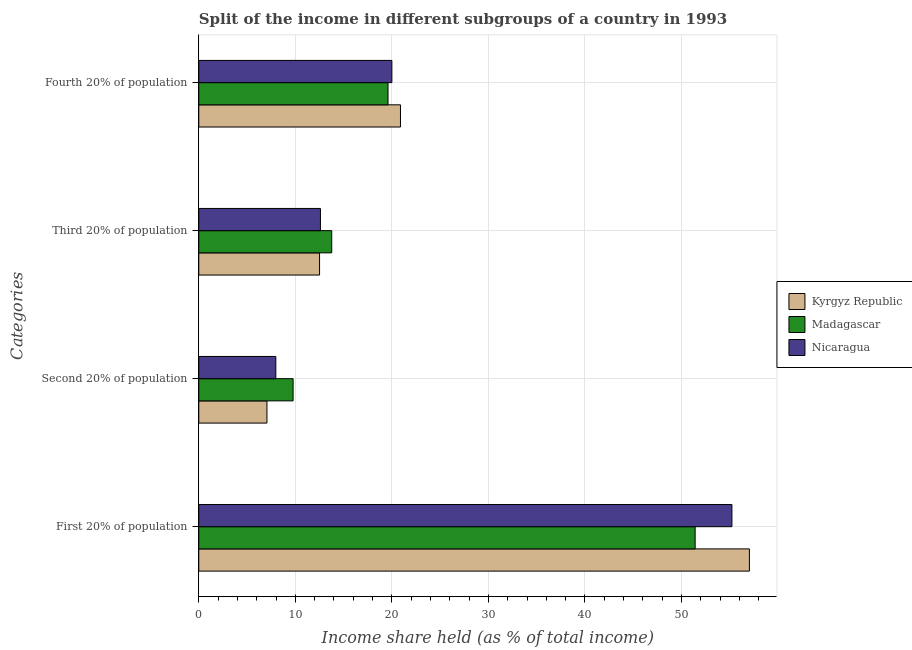How many different coloured bars are there?
Make the answer very short. 3. Are the number of bars per tick equal to the number of legend labels?
Provide a succinct answer. Yes. Are the number of bars on each tick of the Y-axis equal?
Offer a very short reply. Yes. How many bars are there on the 3rd tick from the top?
Your answer should be very brief. 3. What is the label of the 3rd group of bars from the top?
Your response must be concise. Second 20% of population. What is the share of the income held by second 20% of the population in Madagascar?
Provide a short and direct response. 9.77. Across all countries, what is the maximum share of the income held by second 20% of the population?
Offer a very short reply. 9.77. Across all countries, what is the minimum share of the income held by fourth 20% of the population?
Offer a very short reply. 19.6. In which country was the share of the income held by first 20% of the population maximum?
Ensure brevity in your answer.  Kyrgyz Republic. In which country was the share of the income held by second 20% of the population minimum?
Make the answer very short. Kyrgyz Republic. What is the total share of the income held by first 20% of the population in the graph?
Offer a terse response. 163.66. What is the difference between the share of the income held by first 20% of the population in Madagascar and that in Nicaragua?
Your answer should be compact. -3.81. What is the difference between the share of the income held by fourth 20% of the population in Madagascar and the share of the income held by second 20% of the population in Kyrgyz Republic?
Give a very brief answer. 12.54. What is the average share of the income held by first 20% of the population per country?
Offer a terse response. 54.55. What is the difference between the share of the income held by second 20% of the population and share of the income held by first 20% of the population in Kyrgyz Republic?
Offer a terse response. -49.97. What is the ratio of the share of the income held by second 20% of the population in Kyrgyz Republic to that in Nicaragua?
Provide a short and direct response. 0.88. What is the difference between the highest and the second highest share of the income held by third 20% of the population?
Ensure brevity in your answer.  1.17. What is the difference between the highest and the lowest share of the income held by fourth 20% of the population?
Make the answer very short. 1.29. Is the sum of the share of the income held by second 20% of the population in Nicaragua and Kyrgyz Republic greater than the maximum share of the income held by third 20% of the population across all countries?
Offer a terse response. Yes. What does the 2nd bar from the top in Second 20% of population represents?
Provide a succinct answer. Madagascar. What does the 3rd bar from the bottom in Fourth 20% of population represents?
Ensure brevity in your answer.  Nicaragua. Is it the case that in every country, the sum of the share of the income held by first 20% of the population and share of the income held by second 20% of the population is greater than the share of the income held by third 20% of the population?
Your answer should be very brief. Yes. Are all the bars in the graph horizontal?
Offer a very short reply. Yes. Are the values on the major ticks of X-axis written in scientific E-notation?
Offer a very short reply. No. What is the title of the graph?
Provide a succinct answer. Split of the income in different subgroups of a country in 1993. Does "Lesotho" appear as one of the legend labels in the graph?
Keep it short and to the point. No. What is the label or title of the X-axis?
Provide a short and direct response. Income share held (as % of total income). What is the label or title of the Y-axis?
Ensure brevity in your answer.  Categories. What is the Income share held (as % of total income) in Kyrgyz Republic in First 20% of population?
Make the answer very short. 57.03. What is the Income share held (as % of total income) in Madagascar in First 20% of population?
Offer a terse response. 51.41. What is the Income share held (as % of total income) of Nicaragua in First 20% of population?
Your answer should be compact. 55.22. What is the Income share held (as % of total income) of Kyrgyz Republic in Second 20% of population?
Give a very brief answer. 7.06. What is the Income share held (as % of total income) of Madagascar in Second 20% of population?
Your answer should be compact. 9.77. What is the Income share held (as % of total income) in Nicaragua in Second 20% of population?
Keep it short and to the point. 7.98. What is the Income share held (as % of total income) of Kyrgyz Republic in Third 20% of population?
Give a very brief answer. 12.51. What is the Income share held (as % of total income) of Madagascar in Third 20% of population?
Your response must be concise. 13.77. What is the Income share held (as % of total income) of Kyrgyz Republic in Fourth 20% of population?
Offer a very short reply. 20.89. What is the Income share held (as % of total income) in Madagascar in Fourth 20% of population?
Provide a short and direct response. 19.6. What is the Income share held (as % of total income) in Nicaragua in Fourth 20% of population?
Keep it short and to the point. 20. Across all Categories, what is the maximum Income share held (as % of total income) in Kyrgyz Republic?
Your answer should be compact. 57.03. Across all Categories, what is the maximum Income share held (as % of total income) in Madagascar?
Offer a terse response. 51.41. Across all Categories, what is the maximum Income share held (as % of total income) in Nicaragua?
Your answer should be compact. 55.22. Across all Categories, what is the minimum Income share held (as % of total income) of Kyrgyz Republic?
Your response must be concise. 7.06. Across all Categories, what is the minimum Income share held (as % of total income) in Madagascar?
Provide a short and direct response. 9.77. Across all Categories, what is the minimum Income share held (as % of total income) of Nicaragua?
Make the answer very short. 7.98. What is the total Income share held (as % of total income) in Kyrgyz Republic in the graph?
Offer a terse response. 97.49. What is the total Income share held (as % of total income) in Madagascar in the graph?
Your answer should be compact. 94.55. What is the total Income share held (as % of total income) of Nicaragua in the graph?
Provide a short and direct response. 95.8. What is the difference between the Income share held (as % of total income) of Kyrgyz Republic in First 20% of population and that in Second 20% of population?
Offer a terse response. 49.97. What is the difference between the Income share held (as % of total income) of Madagascar in First 20% of population and that in Second 20% of population?
Offer a terse response. 41.64. What is the difference between the Income share held (as % of total income) in Nicaragua in First 20% of population and that in Second 20% of population?
Provide a succinct answer. 47.24. What is the difference between the Income share held (as % of total income) of Kyrgyz Republic in First 20% of population and that in Third 20% of population?
Ensure brevity in your answer.  44.52. What is the difference between the Income share held (as % of total income) of Madagascar in First 20% of population and that in Third 20% of population?
Provide a short and direct response. 37.64. What is the difference between the Income share held (as % of total income) of Nicaragua in First 20% of population and that in Third 20% of population?
Offer a very short reply. 42.62. What is the difference between the Income share held (as % of total income) in Kyrgyz Republic in First 20% of population and that in Fourth 20% of population?
Offer a very short reply. 36.14. What is the difference between the Income share held (as % of total income) of Madagascar in First 20% of population and that in Fourth 20% of population?
Offer a terse response. 31.81. What is the difference between the Income share held (as % of total income) in Nicaragua in First 20% of population and that in Fourth 20% of population?
Ensure brevity in your answer.  35.22. What is the difference between the Income share held (as % of total income) in Kyrgyz Republic in Second 20% of population and that in Third 20% of population?
Make the answer very short. -5.45. What is the difference between the Income share held (as % of total income) in Madagascar in Second 20% of population and that in Third 20% of population?
Your answer should be compact. -4. What is the difference between the Income share held (as % of total income) of Nicaragua in Second 20% of population and that in Third 20% of population?
Make the answer very short. -4.62. What is the difference between the Income share held (as % of total income) of Kyrgyz Republic in Second 20% of population and that in Fourth 20% of population?
Offer a terse response. -13.83. What is the difference between the Income share held (as % of total income) of Madagascar in Second 20% of population and that in Fourth 20% of population?
Ensure brevity in your answer.  -9.83. What is the difference between the Income share held (as % of total income) of Nicaragua in Second 20% of population and that in Fourth 20% of population?
Keep it short and to the point. -12.02. What is the difference between the Income share held (as % of total income) in Kyrgyz Republic in Third 20% of population and that in Fourth 20% of population?
Provide a succinct answer. -8.38. What is the difference between the Income share held (as % of total income) of Madagascar in Third 20% of population and that in Fourth 20% of population?
Provide a succinct answer. -5.83. What is the difference between the Income share held (as % of total income) in Kyrgyz Republic in First 20% of population and the Income share held (as % of total income) in Madagascar in Second 20% of population?
Offer a very short reply. 47.26. What is the difference between the Income share held (as % of total income) in Kyrgyz Republic in First 20% of population and the Income share held (as % of total income) in Nicaragua in Second 20% of population?
Make the answer very short. 49.05. What is the difference between the Income share held (as % of total income) in Madagascar in First 20% of population and the Income share held (as % of total income) in Nicaragua in Second 20% of population?
Ensure brevity in your answer.  43.43. What is the difference between the Income share held (as % of total income) of Kyrgyz Republic in First 20% of population and the Income share held (as % of total income) of Madagascar in Third 20% of population?
Provide a short and direct response. 43.26. What is the difference between the Income share held (as % of total income) of Kyrgyz Republic in First 20% of population and the Income share held (as % of total income) of Nicaragua in Third 20% of population?
Keep it short and to the point. 44.43. What is the difference between the Income share held (as % of total income) of Madagascar in First 20% of population and the Income share held (as % of total income) of Nicaragua in Third 20% of population?
Make the answer very short. 38.81. What is the difference between the Income share held (as % of total income) of Kyrgyz Republic in First 20% of population and the Income share held (as % of total income) of Madagascar in Fourth 20% of population?
Ensure brevity in your answer.  37.43. What is the difference between the Income share held (as % of total income) in Kyrgyz Republic in First 20% of population and the Income share held (as % of total income) in Nicaragua in Fourth 20% of population?
Give a very brief answer. 37.03. What is the difference between the Income share held (as % of total income) of Madagascar in First 20% of population and the Income share held (as % of total income) of Nicaragua in Fourth 20% of population?
Ensure brevity in your answer.  31.41. What is the difference between the Income share held (as % of total income) in Kyrgyz Republic in Second 20% of population and the Income share held (as % of total income) in Madagascar in Third 20% of population?
Your response must be concise. -6.71. What is the difference between the Income share held (as % of total income) in Kyrgyz Republic in Second 20% of population and the Income share held (as % of total income) in Nicaragua in Third 20% of population?
Keep it short and to the point. -5.54. What is the difference between the Income share held (as % of total income) of Madagascar in Second 20% of population and the Income share held (as % of total income) of Nicaragua in Third 20% of population?
Your answer should be very brief. -2.83. What is the difference between the Income share held (as % of total income) in Kyrgyz Republic in Second 20% of population and the Income share held (as % of total income) in Madagascar in Fourth 20% of population?
Your answer should be compact. -12.54. What is the difference between the Income share held (as % of total income) in Kyrgyz Republic in Second 20% of population and the Income share held (as % of total income) in Nicaragua in Fourth 20% of population?
Make the answer very short. -12.94. What is the difference between the Income share held (as % of total income) in Madagascar in Second 20% of population and the Income share held (as % of total income) in Nicaragua in Fourth 20% of population?
Your answer should be very brief. -10.23. What is the difference between the Income share held (as % of total income) of Kyrgyz Republic in Third 20% of population and the Income share held (as % of total income) of Madagascar in Fourth 20% of population?
Your answer should be very brief. -7.09. What is the difference between the Income share held (as % of total income) in Kyrgyz Republic in Third 20% of population and the Income share held (as % of total income) in Nicaragua in Fourth 20% of population?
Your answer should be very brief. -7.49. What is the difference between the Income share held (as % of total income) of Madagascar in Third 20% of population and the Income share held (as % of total income) of Nicaragua in Fourth 20% of population?
Provide a short and direct response. -6.23. What is the average Income share held (as % of total income) in Kyrgyz Republic per Categories?
Give a very brief answer. 24.37. What is the average Income share held (as % of total income) in Madagascar per Categories?
Make the answer very short. 23.64. What is the average Income share held (as % of total income) in Nicaragua per Categories?
Keep it short and to the point. 23.95. What is the difference between the Income share held (as % of total income) of Kyrgyz Republic and Income share held (as % of total income) of Madagascar in First 20% of population?
Your answer should be very brief. 5.62. What is the difference between the Income share held (as % of total income) in Kyrgyz Republic and Income share held (as % of total income) in Nicaragua in First 20% of population?
Offer a terse response. 1.81. What is the difference between the Income share held (as % of total income) of Madagascar and Income share held (as % of total income) of Nicaragua in First 20% of population?
Give a very brief answer. -3.81. What is the difference between the Income share held (as % of total income) in Kyrgyz Republic and Income share held (as % of total income) in Madagascar in Second 20% of population?
Your answer should be very brief. -2.71. What is the difference between the Income share held (as % of total income) of Kyrgyz Republic and Income share held (as % of total income) of Nicaragua in Second 20% of population?
Your answer should be compact. -0.92. What is the difference between the Income share held (as % of total income) in Madagascar and Income share held (as % of total income) in Nicaragua in Second 20% of population?
Offer a terse response. 1.79. What is the difference between the Income share held (as % of total income) in Kyrgyz Republic and Income share held (as % of total income) in Madagascar in Third 20% of population?
Your answer should be very brief. -1.26. What is the difference between the Income share held (as % of total income) of Kyrgyz Republic and Income share held (as % of total income) of Nicaragua in Third 20% of population?
Provide a succinct answer. -0.09. What is the difference between the Income share held (as % of total income) in Madagascar and Income share held (as % of total income) in Nicaragua in Third 20% of population?
Your response must be concise. 1.17. What is the difference between the Income share held (as % of total income) of Kyrgyz Republic and Income share held (as % of total income) of Madagascar in Fourth 20% of population?
Offer a terse response. 1.29. What is the difference between the Income share held (as % of total income) of Kyrgyz Republic and Income share held (as % of total income) of Nicaragua in Fourth 20% of population?
Offer a very short reply. 0.89. What is the difference between the Income share held (as % of total income) of Madagascar and Income share held (as % of total income) of Nicaragua in Fourth 20% of population?
Your answer should be very brief. -0.4. What is the ratio of the Income share held (as % of total income) in Kyrgyz Republic in First 20% of population to that in Second 20% of population?
Ensure brevity in your answer.  8.08. What is the ratio of the Income share held (as % of total income) in Madagascar in First 20% of population to that in Second 20% of population?
Provide a short and direct response. 5.26. What is the ratio of the Income share held (as % of total income) of Nicaragua in First 20% of population to that in Second 20% of population?
Give a very brief answer. 6.92. What is the ratio of the Income share held (as % of total income) in Kyrgyz Republic in First 20% of population to that in Third 20% of population?
Provide a succinct answer. 4.56. What is the ratio of the Income share held (as % of total income) of Madagascar in First 20% of population to that in Third 20% of population?
Your response must be concise. 3.73. What is the ratio of the Income share held (as % of total income) of Nicaragua in First 20% of population to that in Third 20% of population?
Provide a short and direct response. 4.38. What is the ratio of the Income share held (as % of total income) in Kyrgyz Republic in First 20% of population to that in Fourth 20% of population?
Make the answer very short. 2.73. What is the ratio of the Income share held (as % of total income) of Madagascar in First 20% of population to that in Fourth 20% of population?
Keep it short and to the point. 2.62. What is the ratio of the Income share held (as % of total income) in Nicaragua in First 20% of population to that in Fourth 20% of population?
Give a very brief answer. 2.76. What is the ratio of the Income share held (as % of total income) in Kyrgyz Republic in Second 20% of population to that in Third 20% of population?
Offer a terse response. 0.56. What is the ratio of the Income share held (as % of total income) in Madagascar in Second 20% of population to that in Third 20% of population?
Keep it short and to the point. 0.71. What is the ratio of the Income share held (as % of total income) of Nicaragua in Second 20% of population to that in Third 20% of population?
Your response must be concise. 0.63. What is the ratio of the Income share held (as % of total income) in Kyrgyz Republic in Second 20% of population to that in Fourth 20% of population?
Keep it short and to the point. 0.34. What is the ratio of the Income share held (as % of total income) of Madagascar in Second 20% of population to that in Fourth 20% of population?
Your response must be concise. 0.5. What is the ratio of the Income share held (as % of total income) in Nicaragua in Second 20% of population to that in Fourth 20% of population?
Your answer should be very brief. 0.4. What is the ratio of the Income share held (as % of total income) in Kyrgyz Republic in Third 20% of population to that in Fourth 20% of population?
Make the answer very short. 0.6. What is the ratio of the Income share held (as % of total income) in Madagascar in Third 20% of population to that in Fourth 20% of population?
Your answer should be compact. 0.7. What is the ratio of the Income share held (as % of total income) of Nicaragua in Third 20% of population to that in Fourth 20% of population?
Keep it short and to the point. 0.63. What is the difference between the highest and the second highest Income share held (as % of total income) in Kyrgyz Republic?
Your answer should be compact. 36.14. What is the difference between the highest and the second highest Income share held (as % of total income) in Madagascar?
Your answer should be compact. 31.81. What is the difference between the highest and the second highest Income share held (as % of total income) in Nicaragua?
Keep it short and to the point. 35.22. What is the difference between the highest and the lowest Income share held (as % of total income) in Kyrgyz Republic?
Provide a short and direct response. 49.97. What is the difference between the highest and the lowest Income share held (as % of total income) in Madagascar?
Provide a short and direct response. 41.64. What is the difference between the highest and the lowest Income share held (as % of total income) of Nicaragua?
Ensure brevity in your answer.  47.24. 